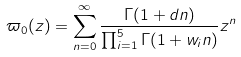<formula> <loc_0><loc_0><loc_500><loc_500>\varpi _ { 0 } ( z ) = \sum _ { n = 0 } ^ { \infty } \frac { \Gamma ( 1 + d n ) } { \prod _ { i = 1 } ^ { 5 } \Gamma ( 1 + w _ { i } n ) } z ^ { n }</formula> 